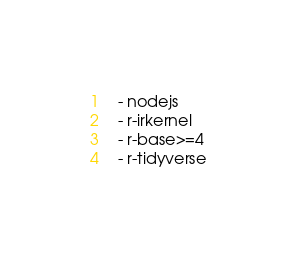Convert code to text. <code><loc_0><loc_0><loc_500><loc_500><_YAML_>  - nodejs
  - r-irkernel
  - r-base>=4
  - r-tidyverse

</code> 